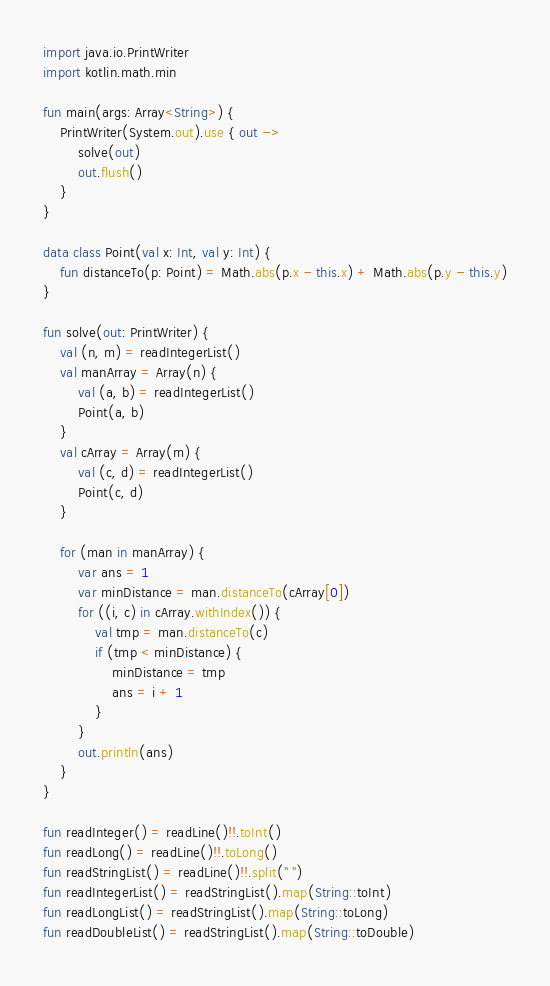<code> <loc_0><loc_0><loc_500><loc_500><_Kotlin_>import java.io.PrintWriter
import kotlin.math.min

fun main(args: Array<String>) {
    PrintWriter(System.out).use { out ->
        solve(out)
        out.flush()
    }
}

data class Point(val x: Int, val y: Int) {
    fun distanceTo(p: Point) = Math.abs(p.x - this.x) + Math.abs(p.y - this.y)
}

fun solve(out: PrintWriter) {
    val (n, m) = readIntegerList()
    val manArray = Array(n) {
        val (a, b) = readIntegerList()
        Point(a, b)
    }
    val cArray = Array(m) {
        val (c, d) = readIntegerList()
        Point(c, d)
    }

    for (man in manArray) {
        var ans = 1
        var minDistance = man.distanceTo(cArray[0])
        for ((i, c) in cArray.withIndex()) {
            val tmp = man.distanceTo(c)
            if (tmp < minDistance) {
                minDistance = tmp
                ans = i + 1
            }
        }
        out.println(ans)
    }
}

fun readInteger() = readLine()!!.toInt()
fun readLong() = readLine()!!.toLong()
fun readStringList() = readLine()!!.split(" ")
fun readIntegerList() = readStringList().map(String::toInt)
fun readLongList() = readStringList().map(String::toLong)
fun readDoubleList() = readStringList().map(String::toDouble)
</code> 